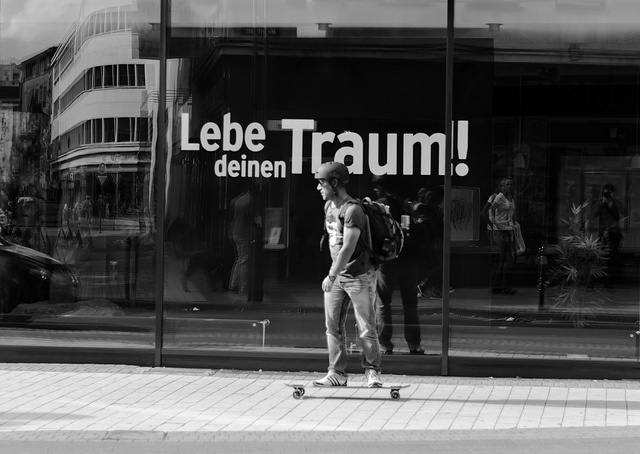Describe the objects in this image and their specific colors. I can see people in darkgray, black, gray, and lightgray tones, people in darkgray, black, gray, and lightgray tones, car in black, gray, and darkgray tones, people in black and darkgray tones, and people in black, gray, and darkgray tones in this image. 